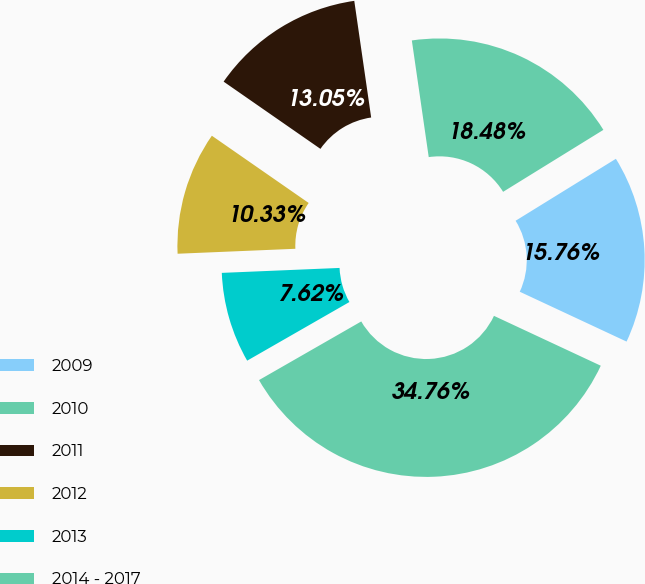<chart> <loc_0><loc_0><loc_500><loc_500><pie_chart><fcel>2009<fcel>2010<fcel>2011<fcel>2012<fcel>2013<fcel>2014 - 2017<nl><fcel>15.76%<fcel>18.48%<fcel>13.05%<fcel>10.33%<fcel>7.62%<fcel>34.76%<nl></chart> 